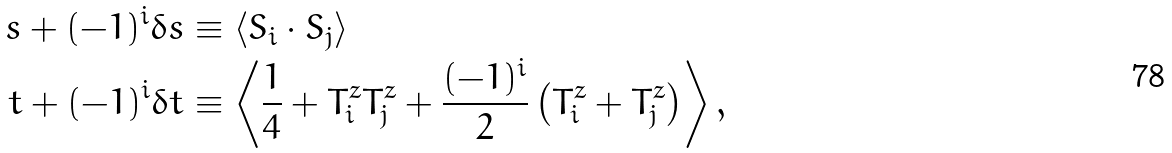<formula> <loc_0><loc_0><loc_500><loc_500>s + ( - 1 ) ^ { i } \delta s & \equiv \left < { S } _ { i } \cdot { S } _ { j } \right > \\ t + ( - 1 ) ^ { i } \delta t & \equiv \left < \frac { 1 } { 4 } + T _ { i } ^ { z } T _ { j } ^ { z } + \frac { ( - 1 ) ^ { i } } { 2 } \left ( T _ { i } ^ { z } + T _ { j } ^ { z } \right ) \right > ,</formula> 